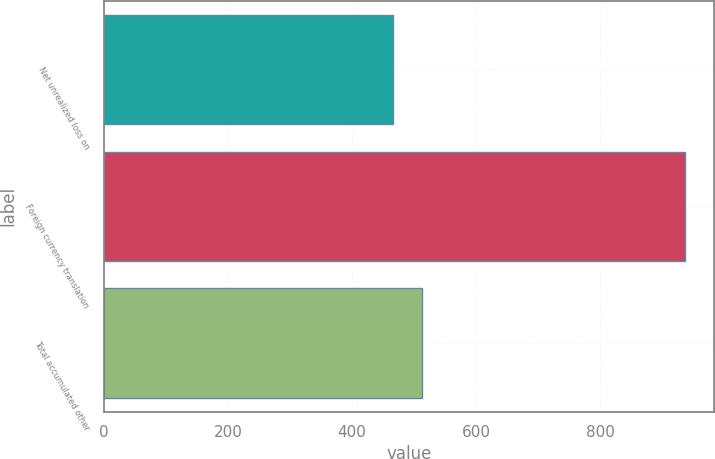Convert chart. <chart><loc_0><loc_0><loc_500><loc_500><bar_chart><fcel>Net unrealized loss on<fcel>Foreign currency translation<fcel>Total accumulated other<nl><fcel>466<fcel>937<fcel>513.1<nl></chart> 